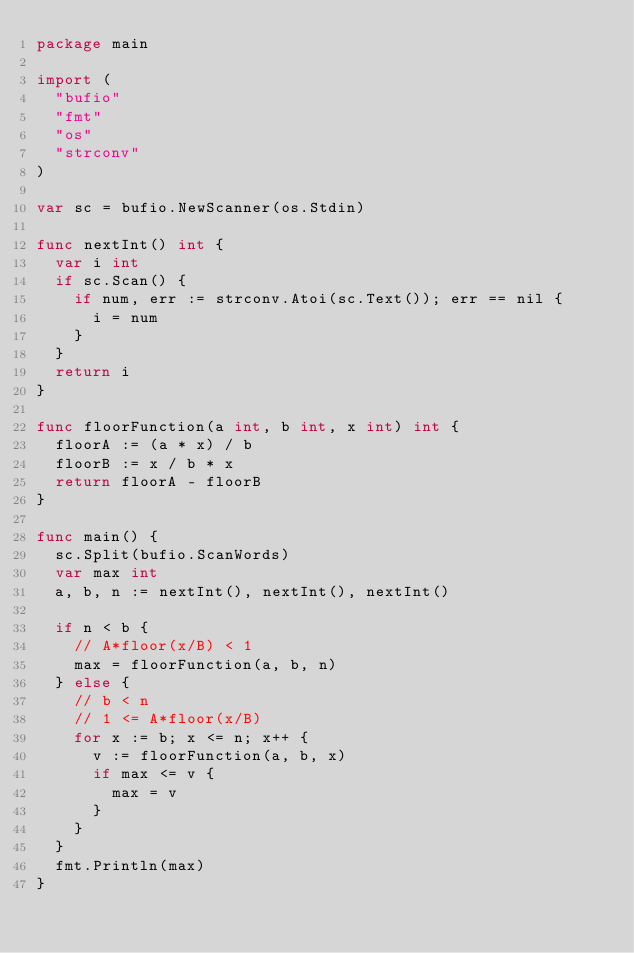Convert code to text. <code><loc_0><loc_0><loc_500><loc_500><_Go_>package main

import (
	"bufio"
	"fmt"
	"os"
	"strconv"
)

var sc = bufio.NewScanner(os.Stdin)

func nextInt() int {
	var i int
	if sc.Scan() {
		if num, err := strconv.Atoi(sc.Text()); err == nil {
			i = num
		}
	}
	return i
}

func floorFunction(a int, b int, x int) int {
	floorA := (a * x) / b
	floorB := x / b * x
	return floorA - floorB
}

func main() {
	sc.Split(bufio.ScanWords)
	var max int
	a, b, n := nextInt(), nextInt(), nextInt()

	if n < b {
		// A*floor(x/B) < 1
		max = floorFunction(a, b, n)
	} else {
		// b < n
		// 1 <= A*floor(x/B)
		for x := b; x <= n; x++ {
			v := floorFunction(a, b, x)
			if max <= v {
				max = v
			}
		}
	}
	fmt.Println(max)
}
</code> 